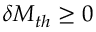Convert formula to latex. <formula><loc_0><loc_0><loc_500><loc_500>\delta M _ { t h } \geq 0</formula> 